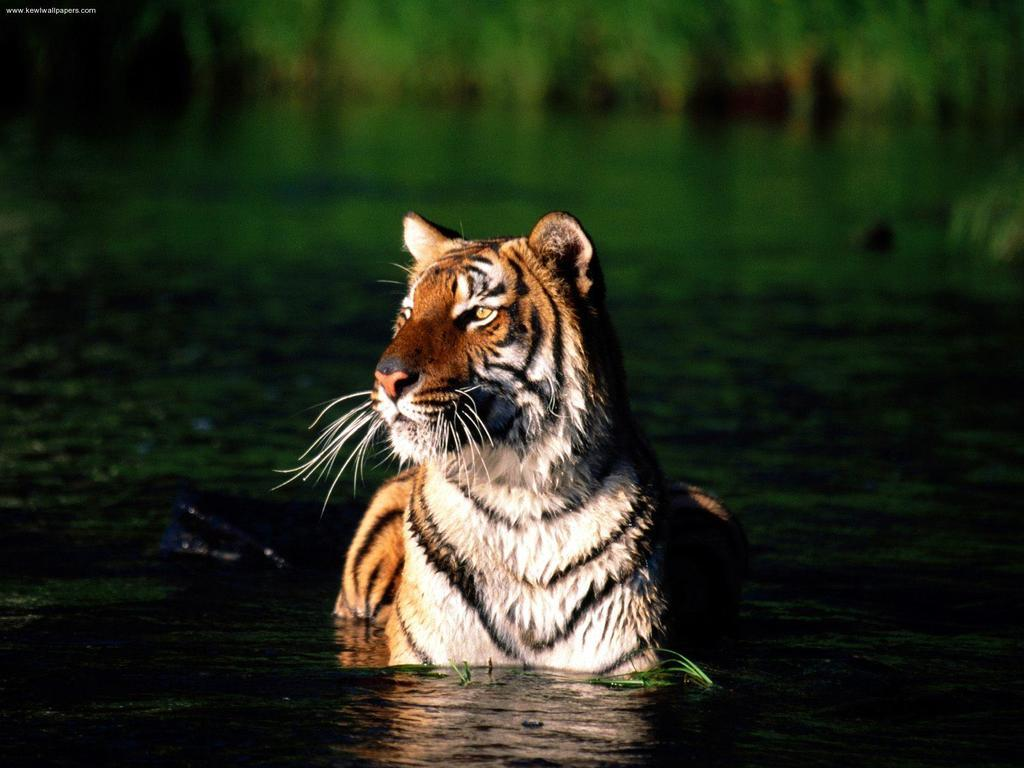What animal can be seen in the water in the image? There is a tiger in the water in the center of the image. Can you describe the background of the image? The background of the image is blurry. Is there any text present in the image? Yes, there is text in the top left corner of the image. How many visitors can be seen in the image? There are no visitors present in the image; it features a tiger in the water. What type of linen is draped over the tiger in the image? There is no linen present in the image; it features a tiger in the water with a blurry background and text in the top left corner. 